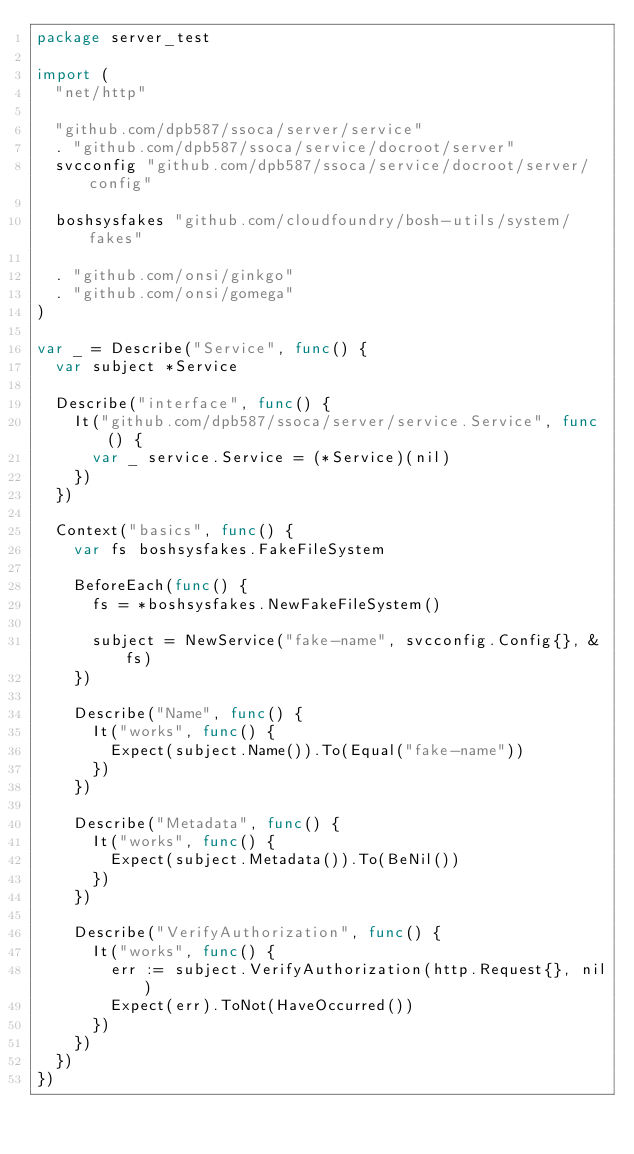Convert code to text. <code><loc_0><loc_0><loc_500><loc_500><_Go_>package server_test

import (
	"net/http"

	"github.com/dpb587/ssoca/server/service"
	. "github.com/dpb587/ssoca/service/docroot/server"
	svcconfig "github.com/dpb587/ssoca/service/docroot/server/config"

	boshsysfakes "github.com/cloudfoundry/bosh-utils/system/fakes"

	. "github.com/onsi/ginkgo"
	. "github.com/onsi/gomega"
)

var _ = Describe("Service", func() {
	var subject *Service

	Describe("interface", func() {
		It("github.com/dpb587/ssoca/server/service.Service", func() {
			var _ service.Service = (*Service)(nil)
		})
	})

	Context("basics", func() {
		var fs boshsysfakes.FakeFileSystem

		BeforeEach(func() {
			fs = *boshsysfakes.NewFakeFileSystem()

			subject = NewService("fake-name", svcconfig.Config{}, &fs)
		})

		Describe("Name", func() {
			It("works", func() {
				Expect(subject.Name()).To(Equal("fake-name"))
			})
		})

		Describe("Metadata", func() {
			It("works", func() {
				Expect(subject.Metadata()).To(BeNil())
			})
		})

		Describe("VerifyAuthorization", func() {
			It("works", func() {
				err := subject.VerifyAuthorization(http.Request{}, nil)
				Expect(err).ToNot(HaveOccurred())
			})
		})
	})
})
</code> 